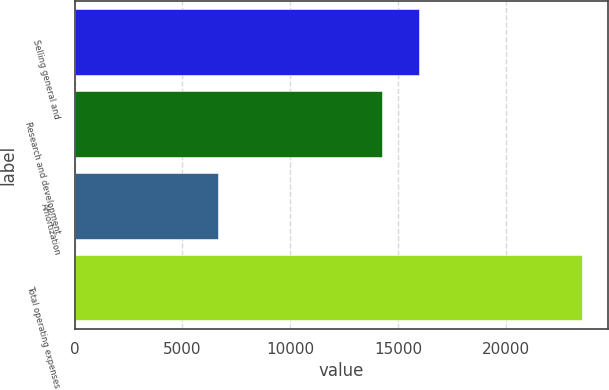Convert chart. <chart><loc_0><loc_0><loc_500><loc_500><bar_chart><fcel>Selling general and<fcel>Research and development<fcel>Amortization<fcel>Total operating expenses<nl><fcel>15951.6<fcel>14262<fcel>6639<fcel>23535<nl></chart> 